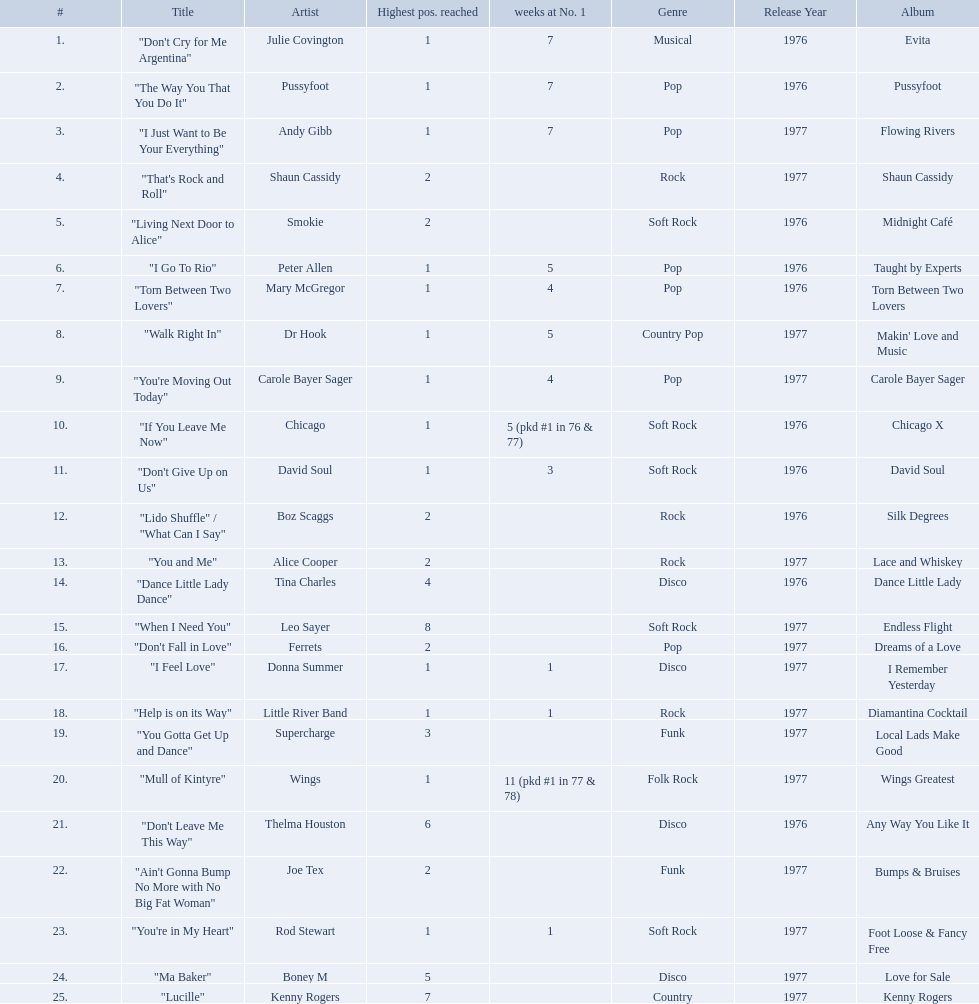Which artists were included in the top 25 singles for 1977 in australia? Julie Covington, Pussyfoot, Andy Gibb, Shaun Cassidy, Smokie, Peter Allen, Mary McGregor, Dr Hook, Carole Bayer Sager, Chicago, David Soul, Boz Scaggs, Alice Cooper, Tina Charles, Leo Sayer, Ferrets, Donna Summer, Little River Band, Supercharge, Wings, Thelma Houston, Joe Tex, Rod Stewart, Boney M, Kenny Rogers. Parse the table in full. {'header': ['#', 'Title', 'Artist', 'Highest pos. reached', 'weeks at No. 1', 'Genre', 'Release Year', 'Album'], 'rows': [['1.', '"Don\'t Cry for Me Argentina"', 'Julie Covington', '1', '7', 'Musical', '1976', 'Evita'], ['2.', '"The Way You That You Do It"', 'Pussyfoot', '1', '7', 'Pop', '1976', 'Pussyfoot'], ['3.', '"I Just Want to Be Your Everything"', 'Andy Gibb', '1', '7', 'Pop', '1977', 'Flowing Rivers'], ['4.', '"That\'s Rock and Roll"', 'Shaun Cassidy', '2', '', 'Rock', '1977', 'Shaun Cassidy'], ['5.', '"Living Next Door to Alice"', 'Smokie', '2', '', 'Soft Rock', '1976', 'Midnight Café'], ['6.', '"I Go To Rio"', 'Peter Allen', '1', '5', 'Pop', '1976', 'Taught by Experts'], ['7.', '"Torn Between Two Lovers"', 'Mary McGregor', '1', '4', 'Pop', '1976', 'Torn Between Two Lovers'], ['8.', '"Walk Right In"', 'Dr Hook', '1', '5', 'Country Pop', '1977', "Makin' Love and Music"], ['9.', '"You\'re Moving Out Today"', 'Carole Bayer Sager', '1', '4', 'Pop', '1977', 'Carole Bayer Sager'], ['10.', '"If You Leave Me Now"', 'Chicago', '1', '5 (pkd #1 in 76 & 77)', 'Soft Rock', '1976', 'Chicago X'], ['11.', '"Don\'t Give Up on Us"', 'David Soul', '1', '3', 'Soft Rock', '1976', 'David Soul'], ['12.', '"Lido Shuffle" / "What Can I Say"', 'Boz Scaggs', '2', '', 'Rock', '1976', 'Silk Degrees'], ['13.', '"You and Me"', 'Alice Cooper', '2', '', 'Rock', '1977', 'Lace and Whiskey'], ['14.', '"Dance Little Lady Dance"', 'Tina Charles', '4', '', 'Disco', '1976', 'Dance Little Lady'], ['15.', '"When I Need You"', 'Leo Sayer', '8', '', 'Soft Rock', '1977', 'Endless Flight'], ['16.', '"Don\'t Fall in Love"', 'Ferrets', '2', '', 'Pop', '1977', 'Dreams of a Love'], ['17.', '"I Feel Love"', 'Donna Summer', '1', '1', 'Disco', '1977', 'I Remember Yesterday'], ['18.', '"Help is on its Way"', 'Little River Band', '1', '1', 'Rock', '1977', 'Diamantina Cocktail'], ['19.', '"You Gotta Get Up and Dance"', 'Supercharge', '3', '', 'Funk', '1977', 'Local Lads Make Good'], ['20.', '"Mull of Kintyre"', 'Wings', '1', '11 (pkd #1 in 77 & 78)', 'Folk Rock', '1977', 'Wings Greatest'], ['21.', '"Don\'t Leave Me This Way"', 'Thelma Houston', '6', '', 'Disco', '1976', 'Any Way You Like It'], ['22.', '"Ain\'t Gonna Bump No More with No Big Fat Woman"', 'Joe Tex', '2', '', 'Funk', '1977', 'Bumps & Bruises'], ['23.', '"You\'re in My Heart"', 'Rod Stewart', '1', '1', 'Soft Rock', '1977', 'Foot Loose & Fancy Free'], ['24.', '"Ma Baker"', 'Boney M', '5', '', 'Disco', '1977', 'Love for Sale'], ['25.', '"Lucille"', 'Kenny Rogers', '7', '', 'Country', '1977', 'Kenny Rogers']]} And for how many weeks did they chart at number 1? 7, 7, 7, , , 5, 4, 5, 4, 5 (pkd #1 in 76 & 77), 3, , , , , , 1, 1, , 11 (pkd #1 in 77 & 78), , , 1, , . Which artist was in the number 1 spot for most time? Wings. 